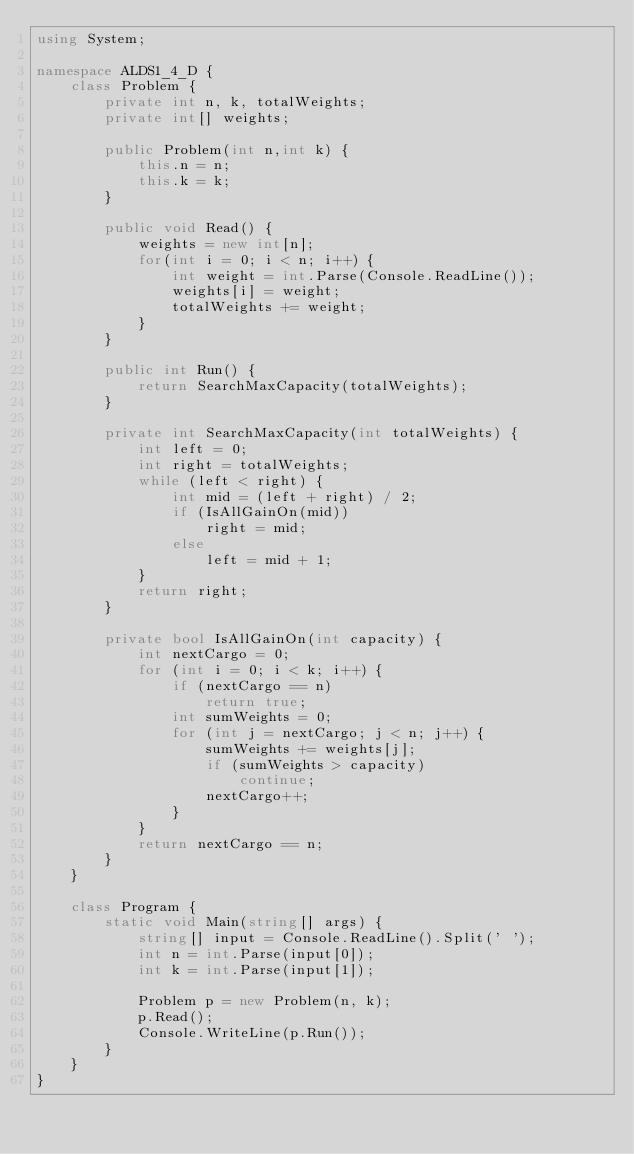Convert code to text. <code><loc_0><loc_0><loc_500><loc_500><_C#_>using System;

namespace ALDS1_4_D {
    class Problem {
        private int n, k, totalWeights;
        private int[] weights;

        public Problem(int n,int k) {
            this.n = n;
            this.k = k;
        }

        public void Read() {
            weights = new int[n];
            for(int i = 0; i < n; i++) {
                int weight = int.Parse(Console.ReadLine());
                weights[i] = weight;
                totalWeights += weight;
            }
        }

        public int Run() {
            return SearchMaxCapacity(totalWeights);
        }

        private int SearchMaxCapacity(int totalWeights) {
            int left = 0;
            int right = totalWeights;
            while (left < right) {
                int mid = (left + right) / 2;
                if (IsAllGainOn(mid))
                    right = mid;
                else
                    left = mid + 1;
            }
            return right;
        }

        private bool IsAllGainOn(int capacity) {
            int nextCargo = 0;
            for (int i = 0; i < k; i++) {
                if (nextCargo == n)
                    return true;
                int sumWeights = 0;
                for (int j = nextCargo; j < n; j++) {
                    sumWeights += weights[j];
                    if (sumWeights > capacity)
                        continue;
                    nextCargo++;
                }
            }
            return nextCargo == n;
        }
    }

    class Program {
        static void Main(string[] args) {
            string[] input = Console.ReadLine().Split(' ');
            int n = int.Parse(input[0]);
            int k = int.Parse(input[1]);

            Problem p = new Problem(n, k);
            p.Read();
            Console.WriteLine(p.Run());
        }
    }
}</code> 